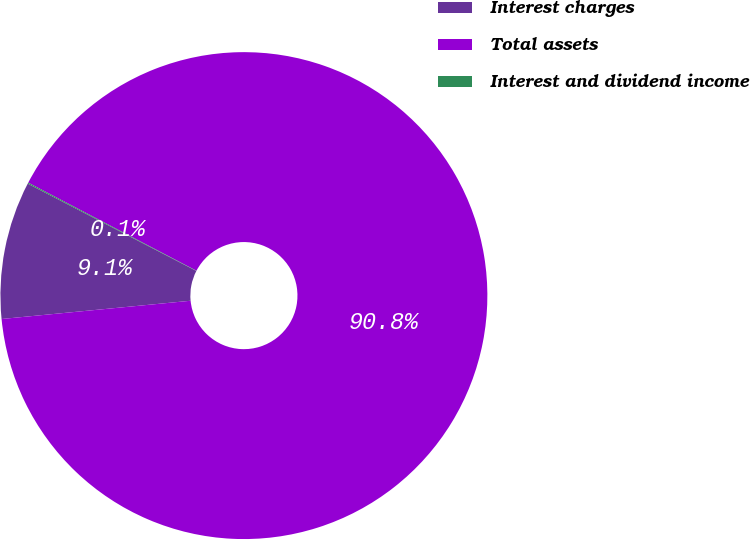Convert chart to OTSL. <chart><loc_0><loc_0><loc_500><loc_500><pie_chart><fcel>Interest charges<fcel>Total assets<fcel>Interest and dividend income<nl><fcel>9.14%<fcel>90.79%<fcel>0.07%<nl></chart> 